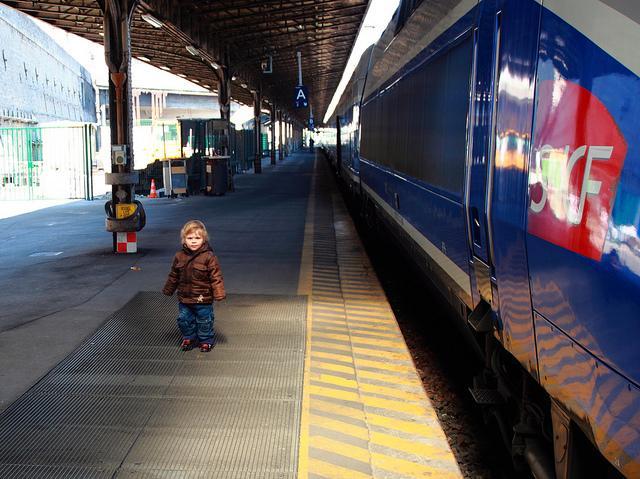What is this child's parent doing? taking picture 